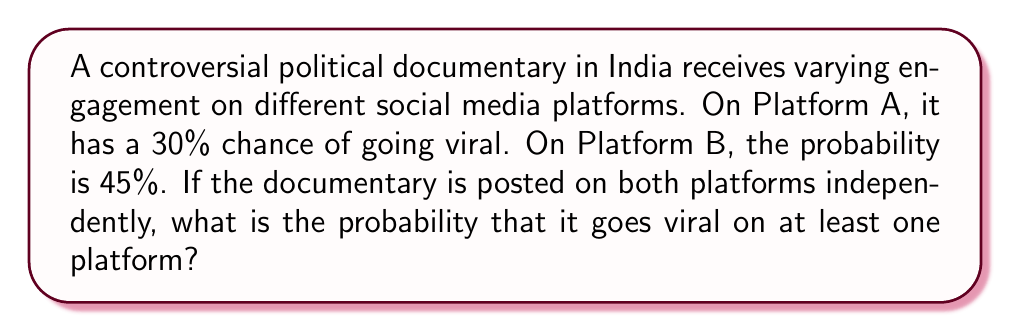Can you answer this question? Let's approach this step-by-step:

1) Let's define our events:
   A: The documentary goes viral on Platform A
   B: The documentary goes viral on Platform B

2) We're given:
   P(A) = 0.30
   P(B) = 0.45

3) We want to find the probability of the documentary going viral on at least one platform. This is equivalent to the probability of it going viral on A OR B.

4) We can use the addition rule of probability:
   P(A or B) = P(A) + P(B) - P(A and B)

5) Since the platforms are independent, we can calculate P(A and B):
   P(A and B) = P(A) × P(B) = 0.30 × 0.45 = 0.135

6) Now we can plug everything into our formula:
   P(A or B) = P(A) + P(B) - P(A and B)
             = 0.30 + 0.45 - 0.135
             = 0.615

7) Therefore, the probability of the documentary going viral on at least one platform is 0.615 or 61.5%.
Answer: 0.615 